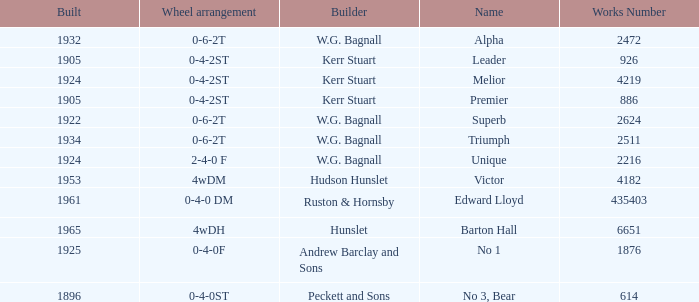What is the work number for Victor? 4182.0. 